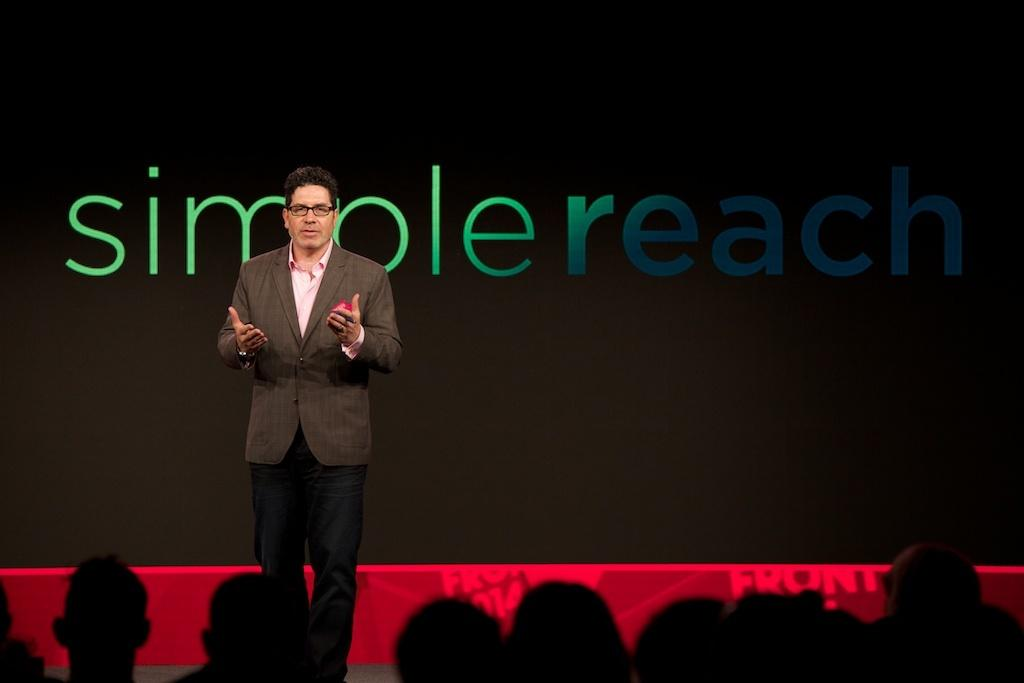What is the main subject of the image? There is a person standing in the image. Can you describe the person's clothing? The person is wearing a brown coat and pants. What is happening in front of the person? There are people in front of the person. What can be seen at the back side of the image? There is a black color banner with "simple reach" written on it. How does the fog affect the person's leg in the image? There is no fog present in the image, so it cannot affect the person's leg. 